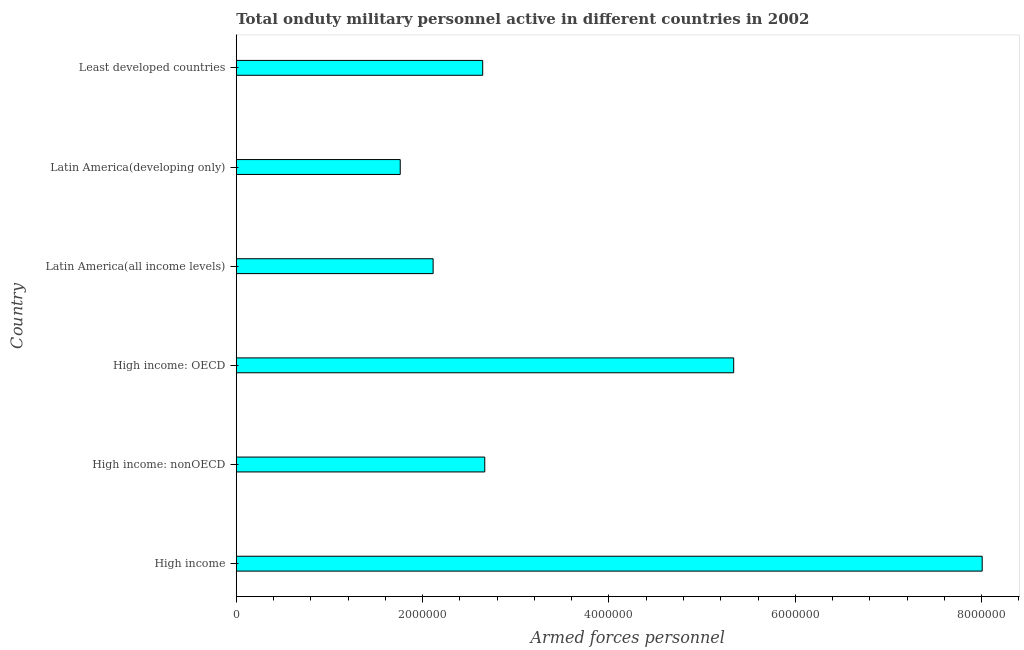Does the graph contain grids?
Give a very brief answer. No. What is the title of the graph?
Give a very brief answer. Total onduty military personnel active in different countries in 2002. What is the label or title of the X-axis?
Ensure brevity in your answer.  Armed forces personnel. What is the label or title of the Y-axis?
Your answer should be very brief. Country. What is the number of armed forces personnel in High income?
Ensure brevity in your answer.  8.01e+06. Across all countries, what is the maximum number of armed forces personnel?
Offer a terse response. 8.01e+06. Across all countries, what is the minimum number of armed forces personnel?
Offer a very short reply. 1.76e+06. In which country was the number of armed forces personnel minimum?
Offer a very short reply. Latin America(developing only). What is the sum of the number of armed forces personnel?
Your response must be concise. 2.25e+07. What is the difference between the number of armed forces personnel in High income: nonOECD and Latin America(developing only)?
Make the answer very short. 9.07e+05. What is the average number of armed forces personnel per country?
Provide a succinct answer. 3.76e+06. What is the median number of armed forces personnel?
Offer a terse response. 2.66e+06. In how many countries, is the number of armed forces personnel greater than 2000000 ?
Your answer should be very brief. 5. What is the ratio of the number of armed forces personnel in High income: nonOECD to that in Latin America(all income levels)?
Provide a succinct answer. 1.26. What is the difference between the highest and the second highest number of armed forces personnel?
Ensure brevity in your answer.  2.67e+06. Is the sum of the number of armed forces personnel in High income and Latin America(developing only) greater than the maximum number of armed forces personnel across all countries?
Provide a succinct answer. Yes. What is the difference between the highest and the lowest number of armed forces personnel?
Provide a succinct answer. 6.25e+06. In how many countries, is the number of armed forces personnel greater than the average number of armed forces personnel taken over all countries?
Provide a succinct answer. 2. How many bars are there?
Offer a very short reply. 6. Are all the bars in the graph horizontal?
Provide a succinct answer. Yes. How many countries are there in the graph?
Your answer should be compact. 6. What is the difference between two consecutive major ticks on the X-axis?
Ensure brevity in your answer.  2.00e+06. Are the values on the major ticks of X-axis written in scientific E-notation?
Your answer should be very brief. No. What is the Armed forces personnel in High income?
Your answer should be compact. 8.01e+06. What is the Armed forces personnel in High income: nonOECD?
Provide a succinct answer. 2.67e+06. What is the Armed forces personnel of High income: OECD?
Make the answer very short. 5.34e+06. What is the Armed forces personnel of Latin America(all income levels)?
Your answer should be very brief. 2.11e+06. What is the Armed forces personnel of Latin America(developing only)?
Ensure brevity in your answer.  1.76e+06. What is the Armed forces personnel of Least developed countries?
Your answer should be compact. 2.65e+06. What is the difference between the Armed forces personnel in High income and High income: nonOECD?
Provide a succinct answer. 5.34e+06. What is the difference between the Armed forces personnel in High income and High income: OECD?
Your answer should be very brief. 2.67e+06. What is the difference between the Armed forces personnel in High income and Latin America(all income levels)?
Give a very brief answer. 5.89e+06. What is the difference between the Armed forces personnel in High income and Latin America(developing only)?
Give a very brief answer. 6.25e+06. What is the difference between the Armed forces personnel in High income and Least developed countries?
Ensure brevity in your answer.  5.36e+06. What is the difference between the Armed forces personnel in High income: nonOECD and High income: OECD?
Offer a terse response. -2.67e+06. What is the difference between the Armed forces personnel in High income: nonOECD and Latin America(all income levels)?
Provide a succinct answer. 5.54e+05. What is the difference between the Armed forces personnel in High income: nonOECD and Latin America(developing only)?
Provide a short and direct response. 9.07e+05. What is the difference between the Armed forces personnel in High income: nonOECD and Least developed countries?
Your response must be concise. 2.22e+04. What is the difference between the Armed forces personnel in High income: OECD and Latin America(all income levels)?
Offer a terse response. 3.23e+06. What is the difference between the Armed forces personnel in High income: OECD and Latin America(developing only)?
Give a very brief answer. 3.58e+06. What is the difference between the Armed forces personnel in High income: OECD and Least developed countries?
Give a very brief answer. 2.69e+06. What is the difference between the Armed forces personnel in Latin America(all income levels) and Latin America(developing only)?
Offer a terse response. 3.53e+05. What is the difference between the Armed forces personnel in Latin America(all income levels) and Least developed countries?
Your answer should be very brief. -5.32e+05. What is the difference between the Armed forces personnel in Latin America(developing only) and Least developed countries?
Your answer should be very brief. -8.85e+05. What is the ratio of the Armed forces personnel in High income to that in High income: nonOECD?
Give a very brief answer. 3. What is the ratio of the Armed forces personnel in High income to that in High income: OECD?
Make the answer very short. 1.5. What is the ratio of the Armed forces personnel in High income to that in Latin America(all income levels)?
Your response must be concise. 3.79. What is the ratio of the Armed forces personnel in High income to that in Latin America(developing only)?
Your answer should be compact. 4.55. What is the ratio of the Armed forces personnel in High income to that in Least developed countries?
Keep it short and to the point. 3.03. What is the ratio of the Armed forces personnel in High income: nonOECD to that in High income: OECD?
Make the answer very short. 0.5. What is the ratio of the Armed forces personnel in High income: nonOECD to that in Latin America(all income levels)?
Give a very brief answer. 1.26. What is the ratio of the Armed forces personnel in High income: nonOECD to that in Latin America(developing only)?
Give a very brief answer. 1.51. What is the ratio of the Armed forces personnel in High income: nonOECD to that in Least developed countries?
Make the answer very short. 1.01. What is the ratio of the Armed forces personnel in High income: OECD to that in Latin America(all income levels)?
Give a very brief answer. 2.53. What is the ratio of the Armed forces personnel in High income: OECD to that in Latin America(developing only)?
Offer a very short reply. 3.03. What is the ratio of the Armed forces personnel in High income: OECD to that in Least developed countries?
Ensure brevity in your answer.  2.02. What is the ratio of the Armed forces personnel in Latin America(all income levels) to that in Latin America(developing only)?
Provide a short and direct response. 1.2. What is the ratio of the Armed forces personnel in Latin America(all income levels) to that in Least developed countries?
Your answer should be very brief. 0.8. What is the ratio of the Armed forces personnel in Latin America(developing only) to that in Least developed countries?
Make the answer very short. 0.67. 